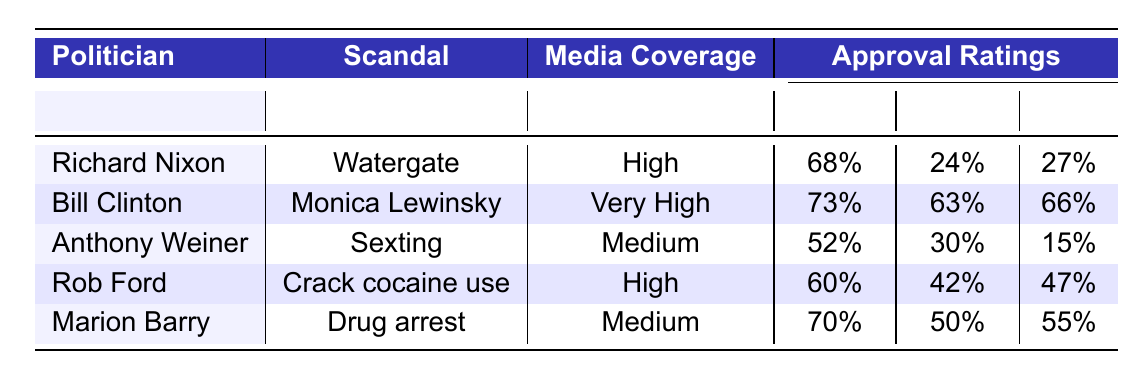What is the media coverage intensity for Bill Clinton? The media coverage intensity for Bill Clinton is listed in the table under the "Media Coverage" column. It shows "Very High" for his involvement in the Monica Lewinsky scandal.
Answer: Very High Which politician had the lowest approval rating during their scandal? To find this, we look at the "During" column under the "Approval Ratings." The lowest value is 24% for Richard Nixon during the Watergate scandal.
Answer: Richard Nixon What is the average approval rating after the scandals for politicians associated with medium media coverage? The politicians with medium media coverage are Anthony Weiner and Marion Barry. Their after scandal approval ratings are 15% and 55% respectively. The average is calculated as (15 + 55)/2 = 35.
Answer: 35 Did Richard Nixon resign after the Watergate scandal? The table indicates whether the politicians resigned in the "Resignation" column. For Richard Nixon, it shows 'true', meaning he did resign.
Answer: Yes Which scandal had a greater drop in approval ratings: Watergate or Sexting? For Watergate, the drop in approval rating is from 68% before to 24% during, a decline of 44%. For Sexting, it drops from 52% before to 30% during, a decline of 22%. Watergate had a greater drop in approval ratings.
Answer: Watergate Is there a correlation between media coverage intensity and approval ratings during the scandals? Analyzing the table, we see politicians with high or very high media coverage generally have more significant drops in approval ratings during scandals compared to those with medium coverage. Thus, a correlation does appear present.
Answer: Yes What was the difference in approval ratings before and after the scandal for Rob Ford? The approval rating for Rob Ford before the scandal was 60% and after it was 47%. The difference is 60% - 47% = 13%.
Answer: 13% Which politician maintained their party support despite their scandal? The party support column shows that Bill Clinton and Marion Barry maintained support.
Answer: Bill Clinton and Marion Barry What percentage of approval rating did Anthony Weiner have before the scandal? The approval rating before the scandal for Anthony Weiner is listed as 52% in the "Before" column under "Approval Ratings."
Answer: 52% 